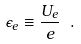<formula> <loc_0><loc_0><loc_500><loc_500>\epsilon _ { e } \equiv \frac { U _ { e } } e \ .</formula> 